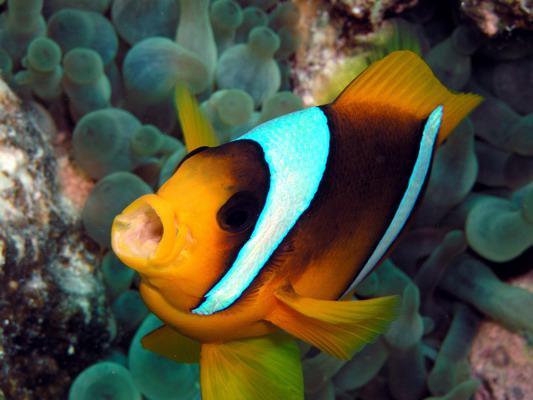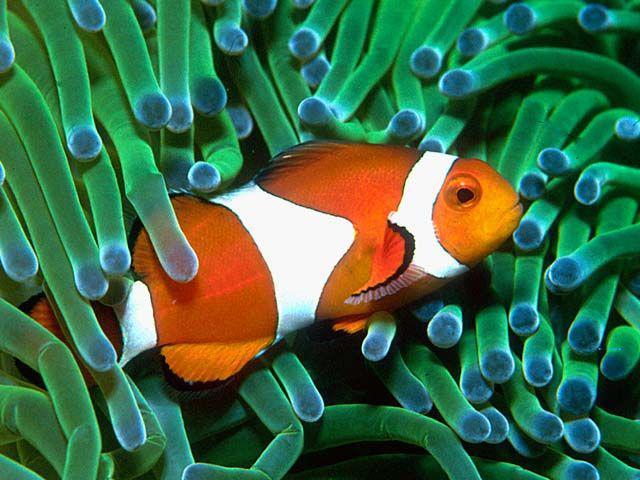The first image is the image on the left, the second image is the image on the right. Examine the images to the left and right. Is the description "A total of two clown fish are shown, facing opposite directions." accurate? Answer yes or no. Yes. 